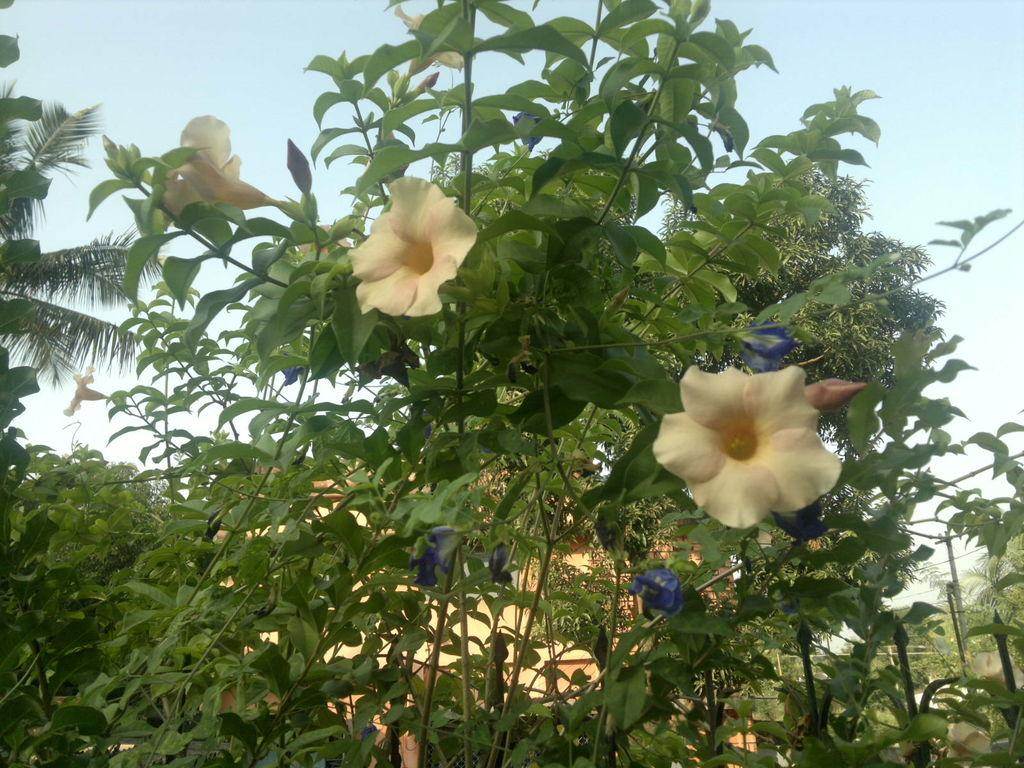What type of flowers can be seen in the image? There are white color flowers in the image. What other types of vegetation are present in the image? There are plants and trees in the image. What can be seen in the background of the image? The sky is visible in the background of the image. What type of curtain is hanging from the tree in the image? There is no curtain present in the image; it features white color flowers, plants, trees, and the sky. 